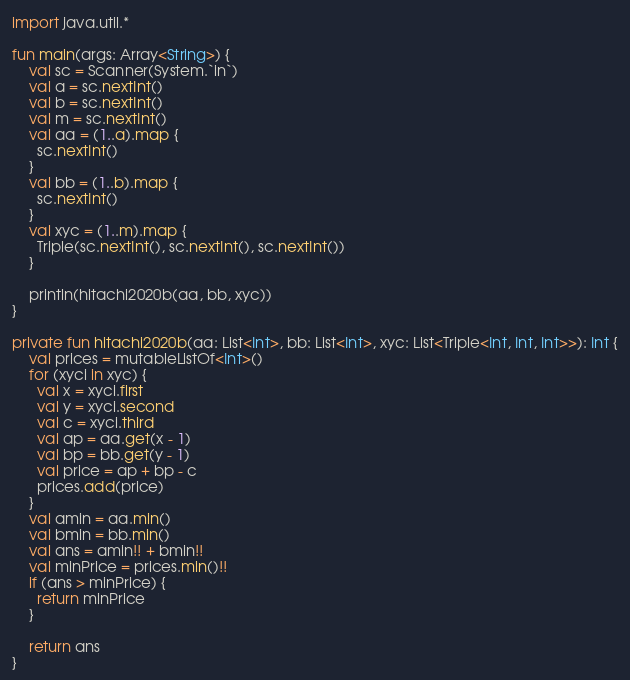Convert code to text. <code><loc_0><loc_0><loc_500><loc_500><_Kotlin_>import java.util.*

fun main(args: Array<String>) {
    val sc = Scanner(System.`in`)
    val a = sc.nextInt()
    val b = sc.nextInt()
    val m = sc.nextInt()
    val aa = (1..a).map {
      sc.nextInt()
    }
    val bb = (1..b).map {
      sc.nextInt()
    }
    val xyc = (1..m).map {
      Triple(sc.nextInt(), sc.nextInt(), sc.nextInt())
    }

    println(hitachi2020b(aa, bb, xyc))
}

private fun hitachi2020b(aa: List<Int>, bb: List<Int>, xyc: List<Triple<Int, Int, Int>>): Int {
    val prices = mutableListOf<Int>()
    for (xyci in xyc) {
      val x = xyci.first
      val y = xyci.second
      val c = xyci.third
      val ap = aa.get(x - 1)
      val bp = bb.get(y - 1)
      val price = ap + bp - c
      prices.add(price)
    }
    val amin = aa.min()
    val bmin = bb.min()
    val ans = amin!! + bmin!!
    val minPrice = prices.min()!!
    if (ans > minPrice) {
      return minPrice
    }

    return ans
}</code> 